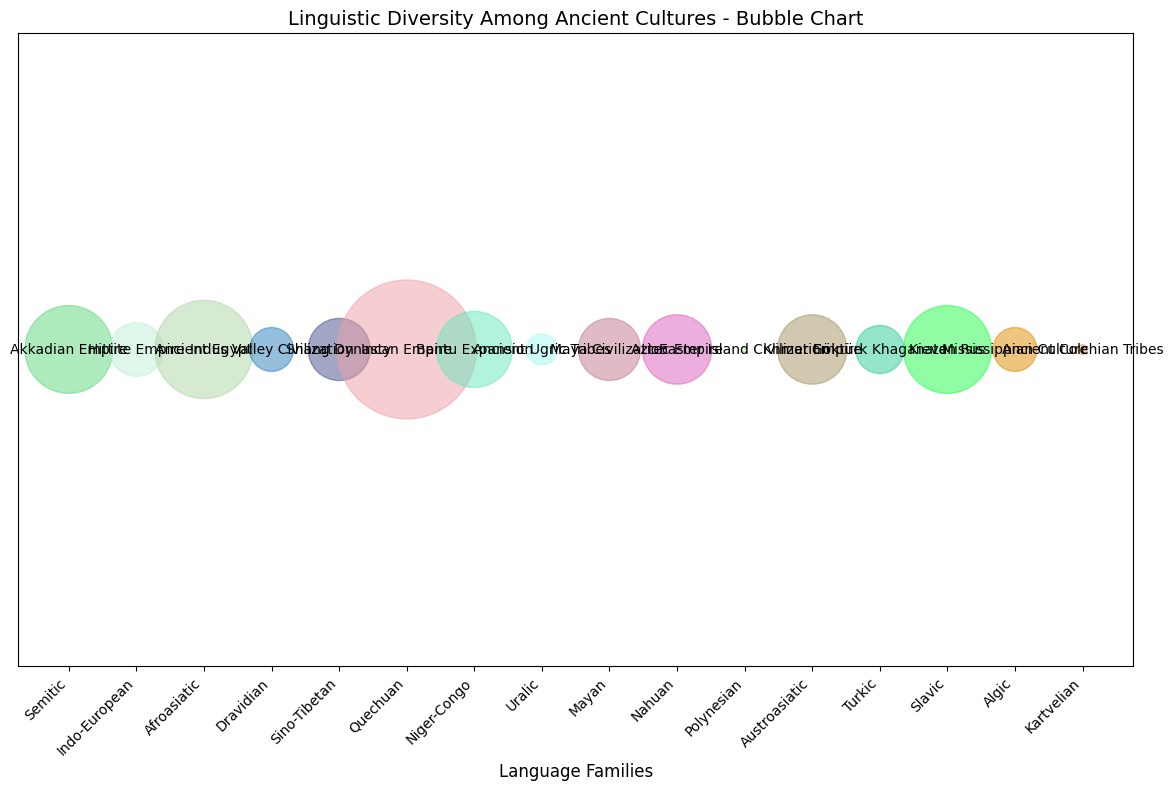Which civilization has the highest number of speakers at its peak? Look for the largest bubble on the chart which represents the civilization with the highest number of speakers. The Incan Empire has the largest bubble.
Answer: Incan Empire Which language family is represented by the civilization with the highest number of speakers? Identify the Incan Empire from the largest bubble, then trace its corresponding language family label.
Answer: Quechuan Which two civilizations had equal numbers of speakers at their peaks? Compare the sizes of the bubbles to find two bubbles of the same size. The Shang Dynasty and Maya Civilization both have equal-sized bubbles.
Answer: Shang Dynasty and Maya Civilization What is the sum of speakers for the Akkadian Empire and the Kievan Rus? Sum the approximate number of speakers for both civilizations (4,000,000 + 4,000,000).
Answer: 8,000,000 Which language family has the smallest bubble on the chart? Find the smallest bubble on the chart which signifies the language family with the smallest number of speakers. The smallest bubble represents the Polynesian language family of the Easter Island Civilization.
Answer: Polynesian Compare the number of speakers between the Aztec Empire and the Khmer Empire. Which is larger and by how much? The Aztec Empire has 2,500,000 speakers, and the Khmer Empire has 2,500,000 speakers. Both civilizations have the same number of speakers.
Answer: Both equal Between the Ancient Ugric Tribes and the Ancient Colchian Tribes, which had more speakers and by how much? The Ancient Ugric Tribes had 500,000 speakers, and the Ancient Colchian Tribes had 50,000 speakers. Subtract to find the difference (500,000 - 50,000).
Answer: Ancient Ugric Tribes by 450,000 Among the language families visually represented by bubbles, which one had approximately 5,000,000 speakers? Find the bubble representing 5,000,000 speakers. It belongs to the Afroasiatic language family linked to Ancient Egypt.
Answer: Afroasiatic Which ancient civilization is associated with the Dravidian language family, and what is the approximate number of its speakers? Locate the Dravidian language family on the x-axis and find its corresponding civilization, which is the Indus Valley Civilization with 1,000,000 speakers.
Answer: Indus Valley Civilization, 1,000,000 speakers 